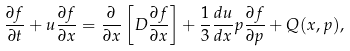<formula> <loc_0><loc_0><loc_500><loc_500>\frac { \partial f } { \partial t } + u \frac { \partial f } { \partial x } = \frac { \partial } { \partial x } \left [ D \frac { \partial f } { \partial x } \right ] + \frac { 1 } { 3 } \frac { d u } { d x } p \frac { \partial f } { \partial p } + Q ( x , p ) ,</formula> 